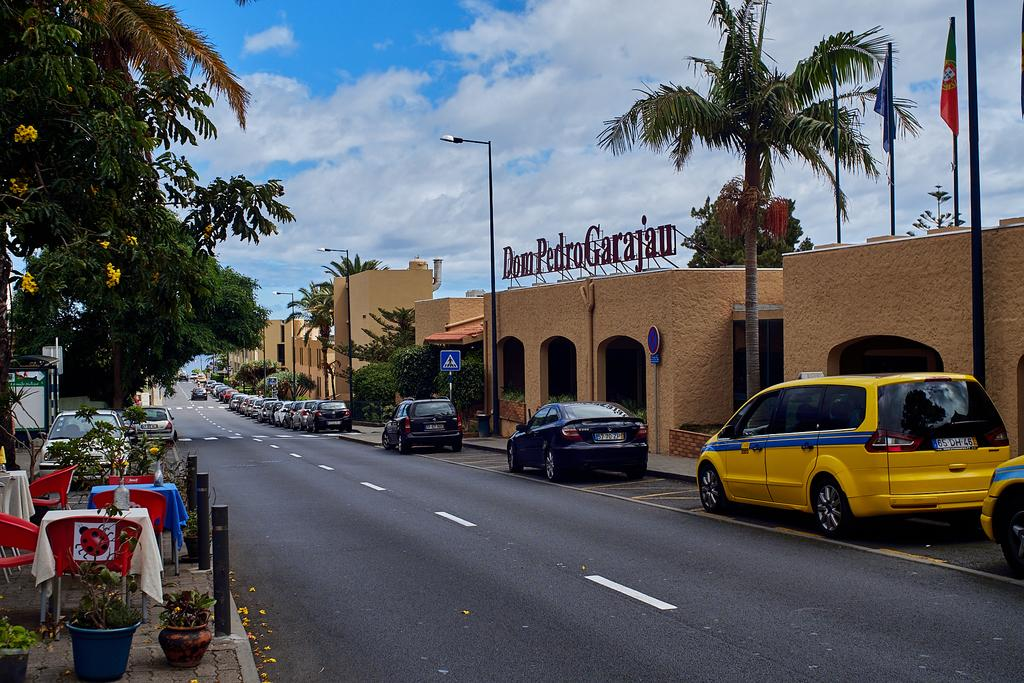Provide a one-sentence caption for the provided image. A number of cars are parked on the street in front of Don Pedro Garajan. 